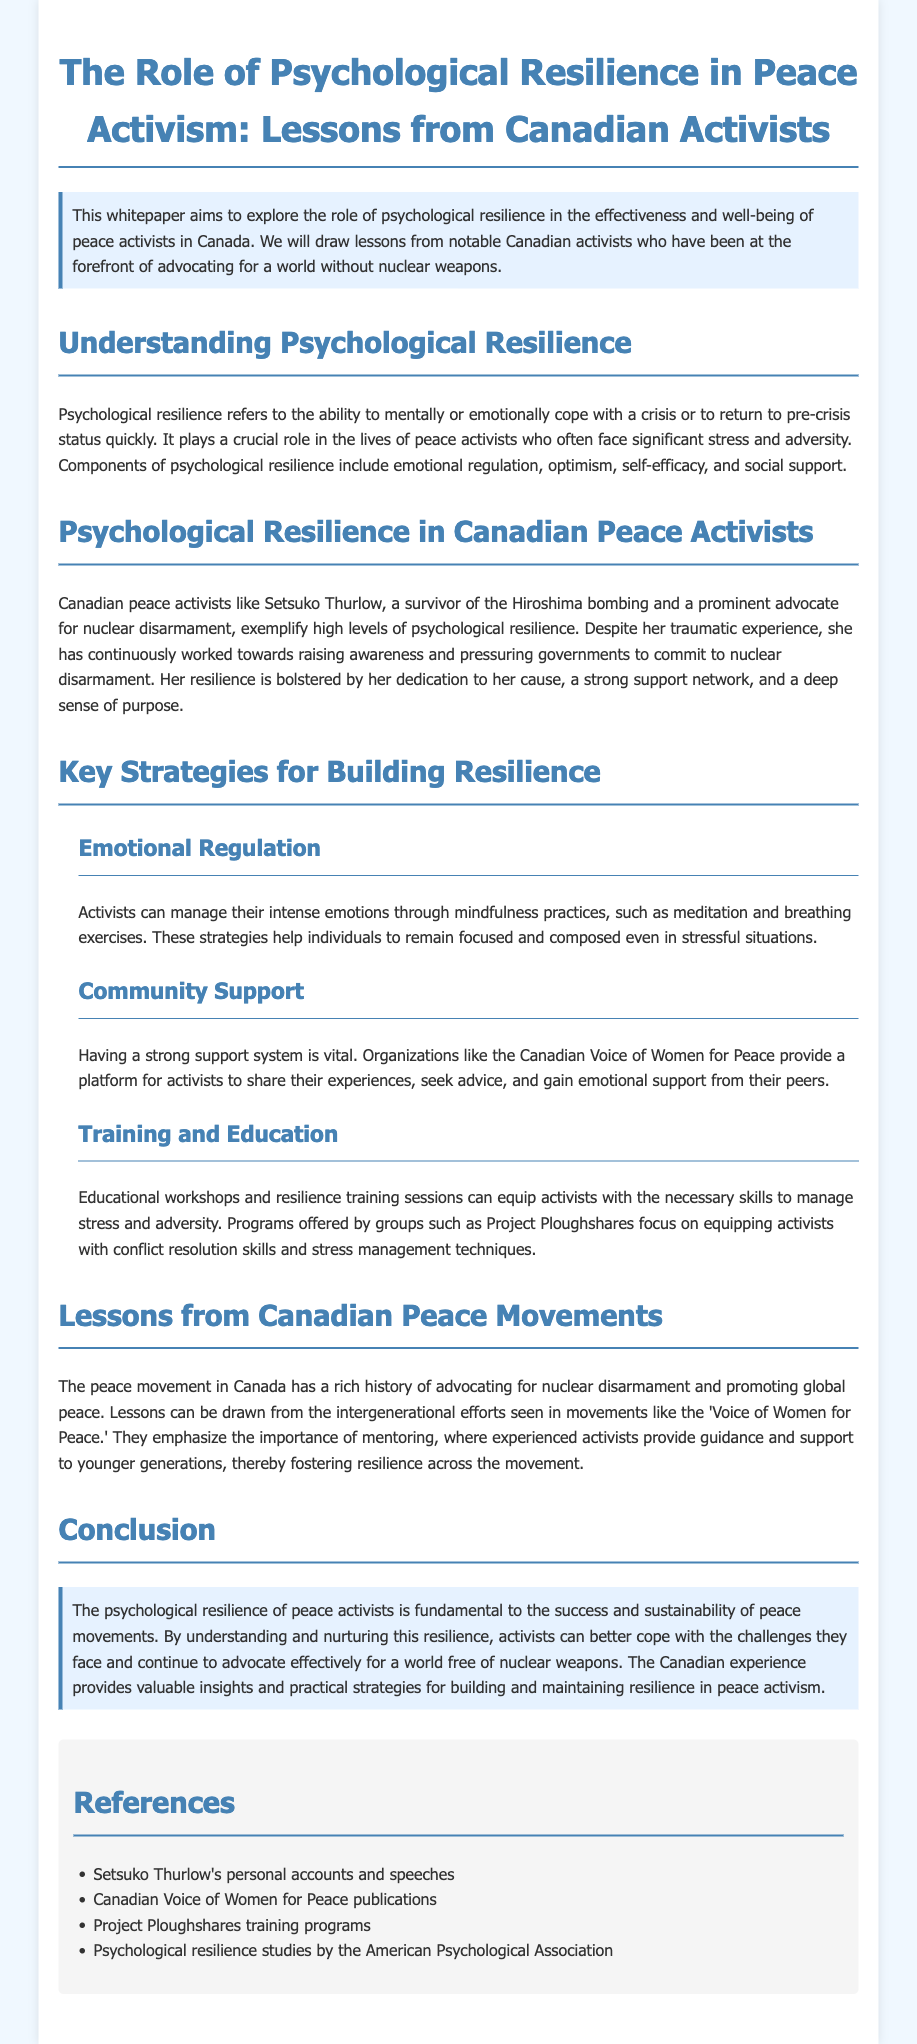What is the primary focus of the whitepaper? The primary focus is to explore the role of psychological resilience in peace activists in Canada.
Answer: psychological resilience Who is a notable Canadian peace activist mentioned in the document? The document mentions Setsuko Thurlow as a notable activist.
Answer: Setsuko Thurlow What crucial role does psychological resilience play for peace activists? Psychological resilience helps activists cope with significant stress and adversity.
Answer: cope with stress Name one component of psychological resilience listed in the document. The document lists emotional regulation as a component of resilience.
Answer: emotional regulation Which organization is mentioned as supporting community among activists? The Canadian Voice of Women for Peace is mentioned as a supportive organization.
Answer: Canadian Voice of Women for Peace What type of support can enhance resilience according to the document? A strong support system enhances resilience.
Answer: strong support system How does the document suggest activists can manage their emotions? Mindfulness practices, such as meditation, can help manage emotions.
Answer: mindfulness practices What does the whitepaper emphasize about mentoring in peace movements? The document emphasizes that mentoring fosters resilience across the movement.
Answer: fosters resilience Which publication is referenced in relation to training programs for activists? Project Ploughshares training programs are referenced for educational workshops.
Answer: Project Ploughshares training programs 